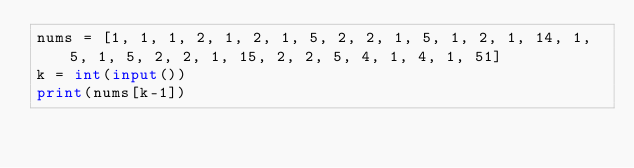<code> <loc_0><loc_0><loc_500><loc_500><_Python_>nums = [1, 1, 1, 2, 1, 2, 1, 5, 2, 2, 1, 5, 1, 2, 1, 14, 1, 5, 1, 5, 2, 2, 1, 15, 2, 2, 5, 4, 1, 4, 1, 51]
k = int(input())
print(nums[k-1])</code> 